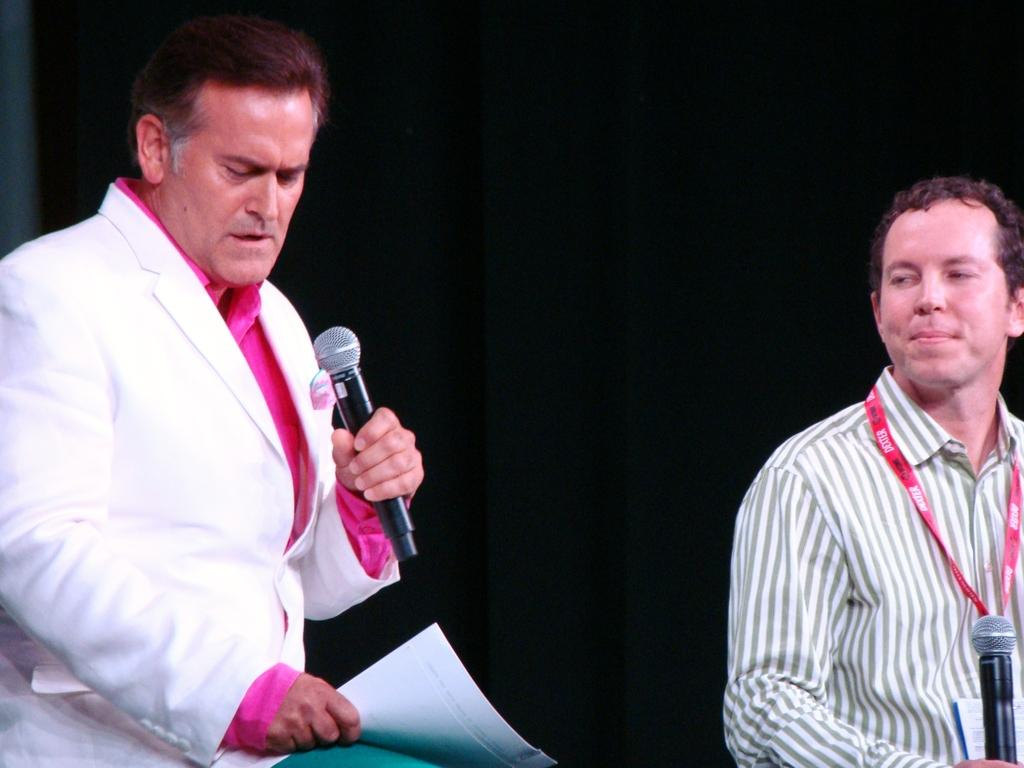What is the main subject of the image? The main subject of the image is a man. What is the man in the image doing? The man is speaking. What object is the man holding in the image? The man is holding a microphone. Are there any other people in the image? Yes, there is another man in the image. What is the second man in the image doing? The second man is also holding a microphone. Can you see a snake slithering across the floor in the image? No, there is no snake present in the image. What type of goose is standing next to the man with the microphone? There is no goose present in the image. 